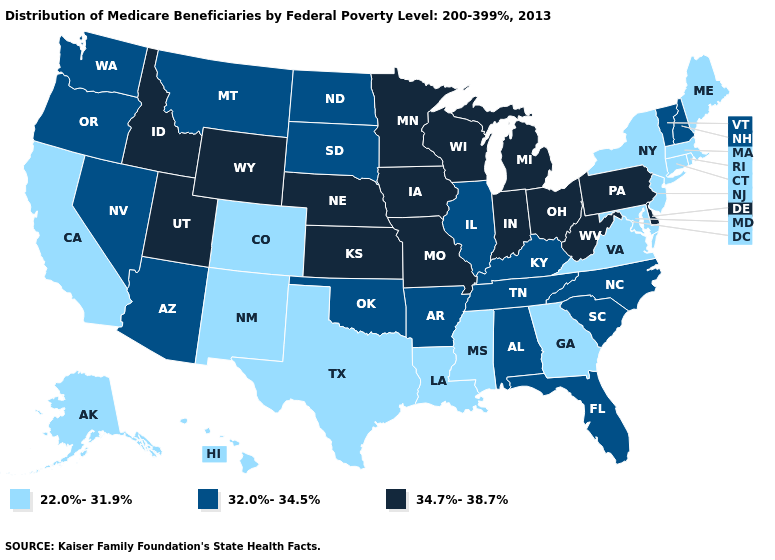What is the lowest value in the USA?
Answer briefly. 22.0%-31.9%. Does Connecticut have the lowest value in the USA?
Keep it brief. Yes. Does South Dakota have a lower value than Connecticut?
Quick response, please. No. Does South Dakota have a lower value than Alabama?
Write a very short answer. No. Among the states that border Oklahoma , which have the lowest value?
Write a very short answer. Colorado, New Mexico, Texas. Does the first symbol in the legend represent the smallest category?
Quick response, please. Yes. Does Washington have the lowest value in the USA?
Quick response, please. No. Which states have the highest value in the USA?
Give a very brief answer. Delaware, Idaho, Indiana, Iowa, Kansas, Michigan, Minnesota, Missouri, Nebraska, Ohio, Pennsylvania, Utah, West Virginia, Wisconsin, Wyoming. Name the states that have a value in the range 32.0%-34.5%?
Short answer required. Alabama, Arizona, Arkansas, Florida, Illinois, Kentucky, Montana, Nevada, New Hampshire, North Carolina, North Dakota, Oklahoma, Oregon, South Carolina, South Dakota, Tennessee, Vermont, Washington. What is the value of Alabama?
Quick response, please. 32.0%-34.5%. How many symbols are there in the legend?
Give a very brief answer. 3. What is the value of Louisiana?
Short answer required. 22.0%-31.9%. Does Wyoming have a higher value than Massachusetts?
Short answer required. Yes. Name the states that have a value in the range 32.0%-34.5%?
Give a very brief answer. Alabama, Arizona, Arkansas, Florida, Illinois, Kentucky, Montana, Nevada, New Hampshire, North Carolina, North Dakota, Oklahoma, Oregon, South Carolina, South Dakota, Tennessee, Vermont, Washington. Does Idaho have a higher value than Nebraska?
Write a very short answer. No. 